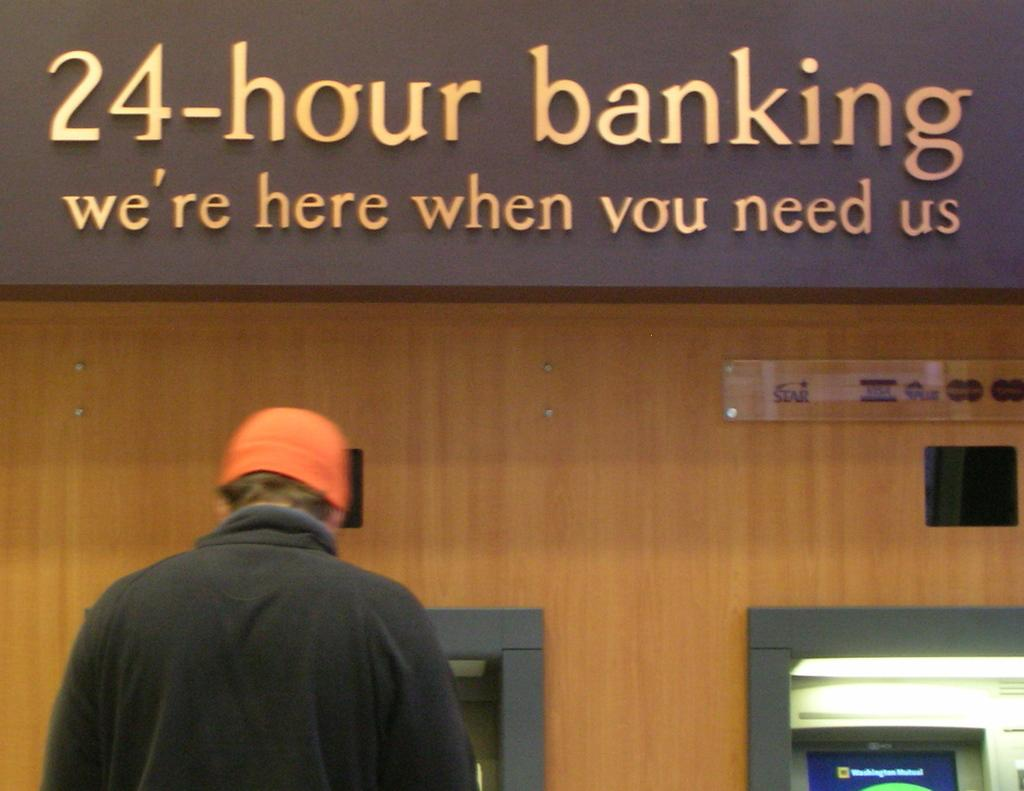How many machines can be seen in the image? There are two machines in the image. What is the person in the image doing? The person is standing in front of one of the machines. What type of material is the wall behind the machines made of? The wall behind the machines is made of wood. What is written or displayed at the top of a board or wall in the image? There is text visible at the top of a board or wall. What type of voyage is the person embarking on in the image? There is no indication of a voyage in the image; it features two machines and a person standing in front of one of them. Can you see any sea creatures in the image? There are no sea creatures present in the image. 